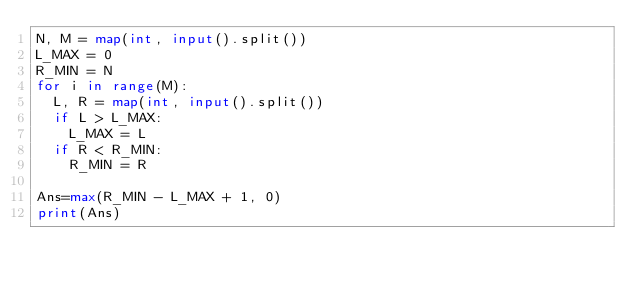<code> <loc_0><loc_0><loc_500><loc_500><_Python_>N, M = map(int, input().split())
L_MAX = 0
R_MIN = N
for i in range(M):
  L, R = map(int, input().split())
  if L > L_MAX:
    L_MAX = L
  if R < R_MIN:
    R_MIN = R

Ans=max(R_MIN - L_MAX + 1, 0)
print(Ans)
  </code> 